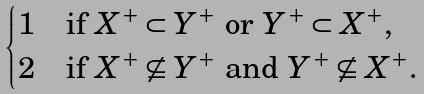<formula> <loc_0><loc_0><loc_500><loc_500>\begin{cases} 1 & \text {if $X^{+}\subset Y^{+}$ or $Y^{+}\subset X^{+}$,} \\ 2 & \text {if $X^{+}\not\subseteq Y^{+}$ and $Y^{+}\not\subseteq X^{+}$.} \end{cases}</formula> 